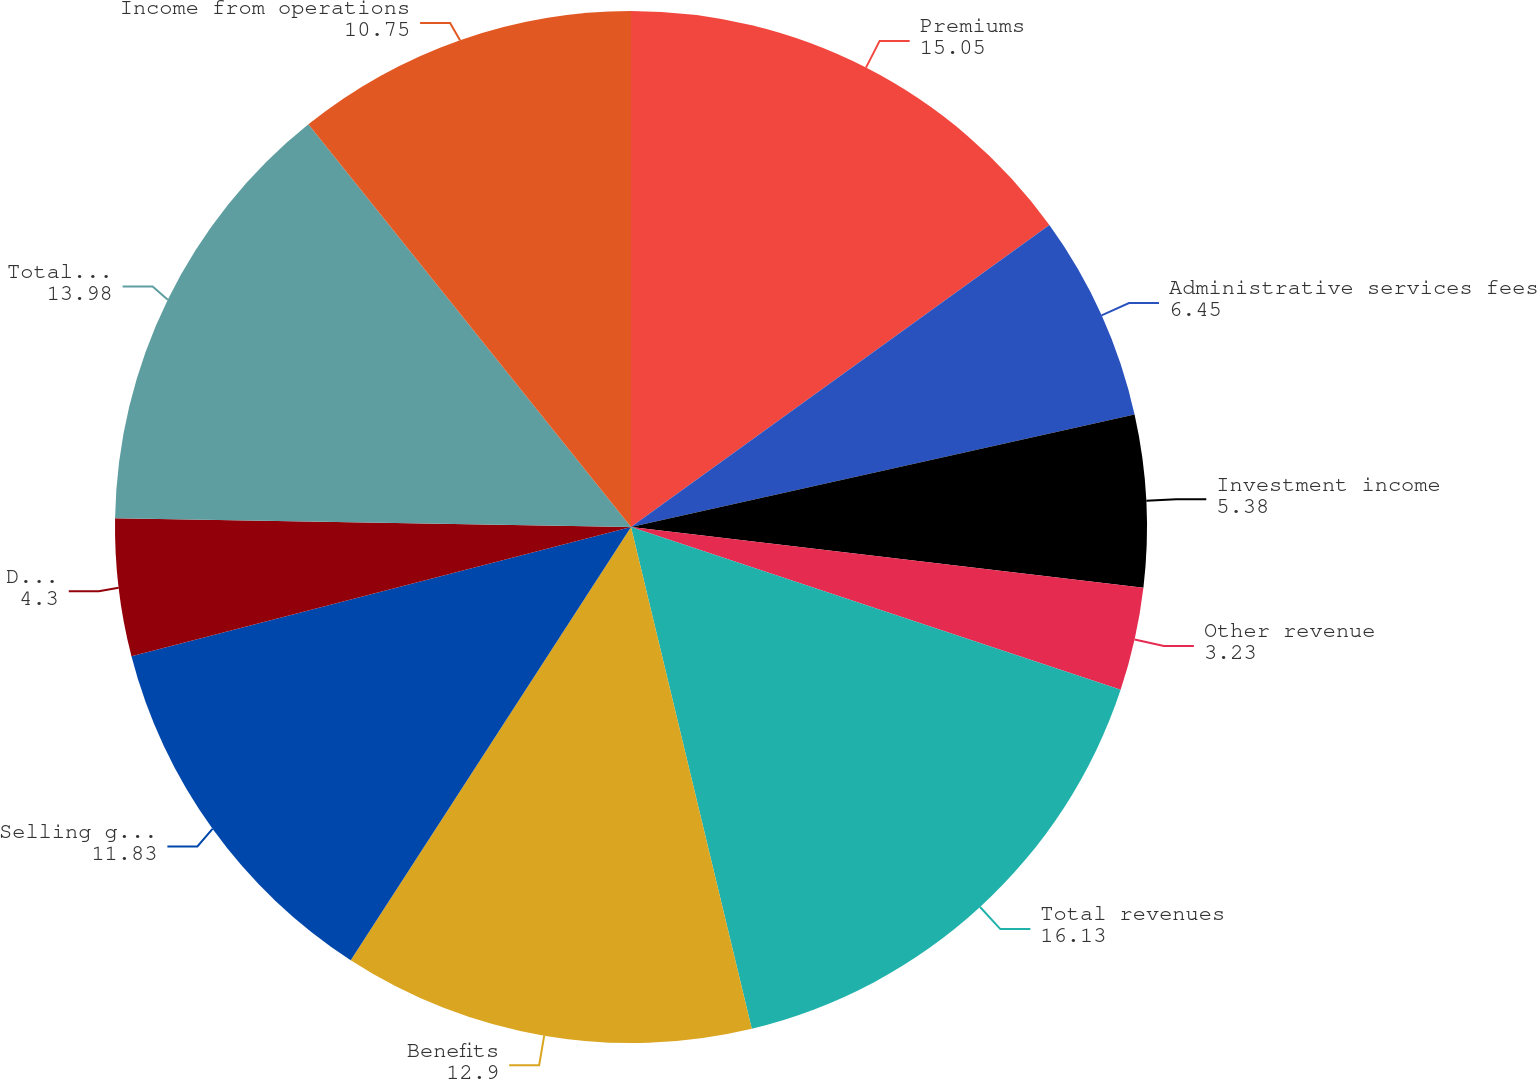Convert chart. <chart><loc_0><loc_0><loc_500><loc_500><pie_chart><fcel>Premiums<fcel>Administrative services fees<fcel>Investment income<fcel>Other revenue<fcel>Total revenues<fcel>Benefits<fcel>Selling general and<fcel>Depreciation and amortization<fcel>Total operating expenses<fcel>Income from operations<nl><fcel>15.05%<fcel>6.45%<fcel>5.38%<fcel>3.23%<fcel>16.13%<fcel>12.9%<fcel>11.83%<fcel>4.3%<fcel>13.98%<fcel>10.75%<nl></chart> 